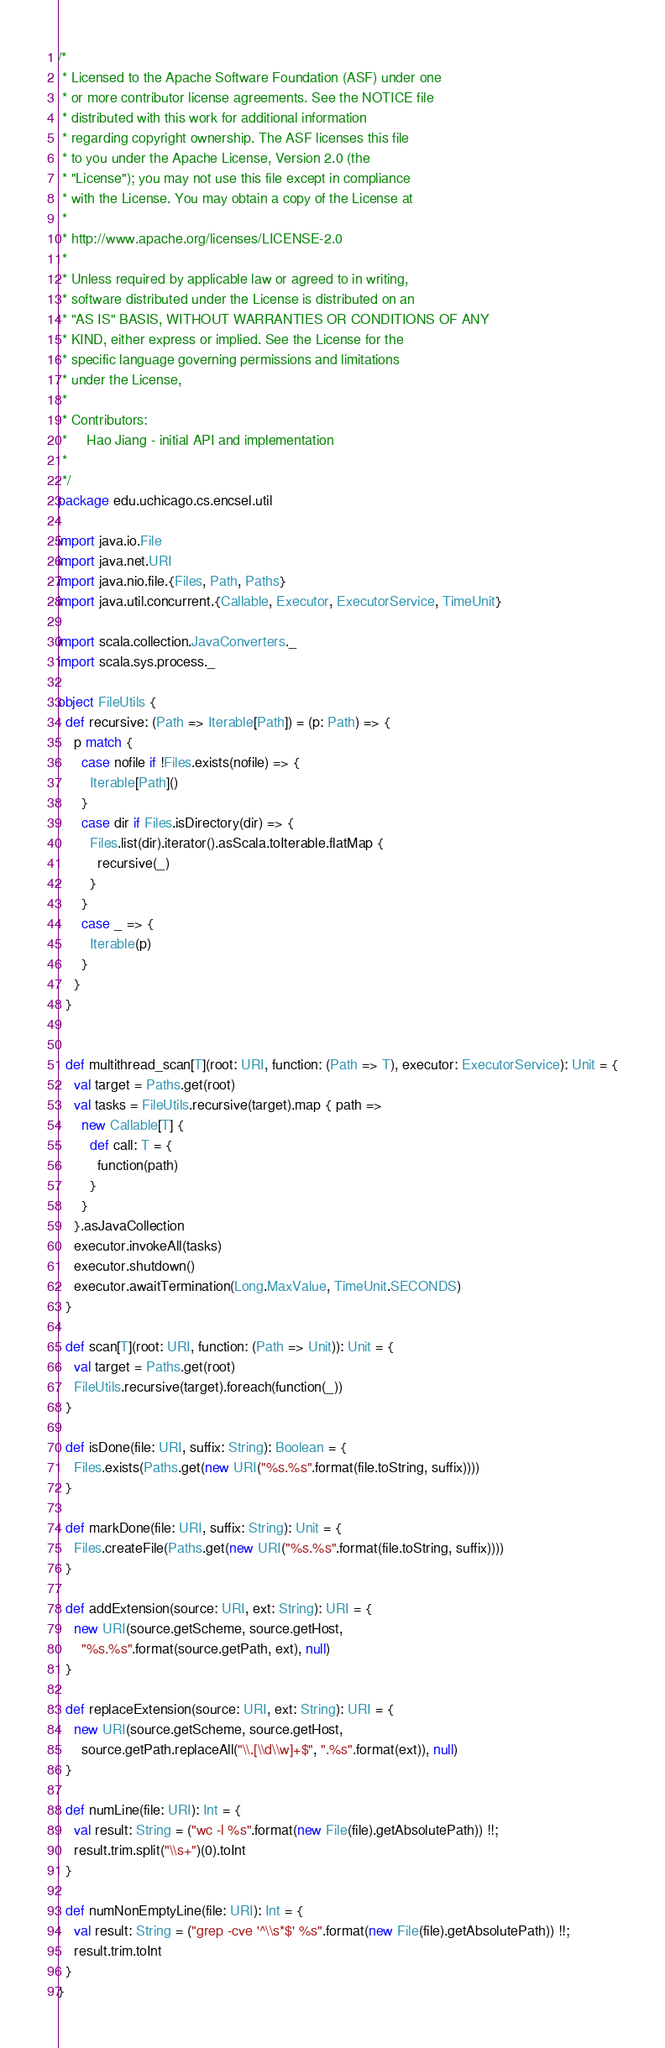Convert code to text. <code><loc_0><loc_0><loc_500><loc_500><_Scala_>/*
 * Licensed to the Apache Software Foundation (ASF) under one
 * or more contributor license agreements. See the NOTICE file
 * distributed with this work for additional information
 * regarding copyright ownership. The ASF licenses this file
 * to you under the Apache License, Version 2.0 (the
 * "License"); you may not use this file except in compliance
 * with the License. You may obtain a copy of the License at
 *
 * http://www.apache.org/licenses/LICENSE-2.0
 *
 * Unless required by applicable law or agreed to in writing,
 * software distributed under the License is distributed on an
 * "AS IS" BASIS, WITHOUT WARRANTIES OR CONDITIONS OF ANY
 * KIND, either express or implied. See the License for the
 * specific language governing permissions and limitations
 * under the License,
 *
 * Contributors:
 *     Hao Jiang - initial API and implementation
 *
 */
package edu.uchicago.cs.encsel.util

import java.io.File
import java.net.URI
import java.nio.file.{Files, Path, Paths}
import java.util.concurrent.{Callable, Executor, ExecutorService, TimeUnit}

import scala.collection.JavaConverters._
import scala.sys.process._

object FileUtils {
  def recursive: (Path => Iterable[Path]) = (p: Path) => {
    p match {
      case nofile if !Files.exists(nofile) => {
        Iterable[Path]()
      }
      case dir if Files.isDirectory(dir) => {
        Files.list(dir).iterator().asScala.toIterable.flatMap {
          recursive(_)
        }
      }
      case _ => {
        Iterable(p)
      }
    }
  }


  def multithread_scan[T](root: URI, function: (Path => T), executor: ExecutorService): Unit = {
    val target = Paths.get(root)
    val tasks = FileUtils.recursive(target).map { path =>
      new Callable[T] {
        def call: T = {
          function(path)
        }
      }
    }.asJavaCollection
    executor.invokeAll(tasks)
    executor.shutdown()
    executor.awaitTermination(Long.MaxValue, TimeUnit.SECONDS)
  }

  def scan[T](root: URI, function: (Path => Unit)): Unit = {
    val target = Paths.get(root)
    FileUtils.recursive(target).foreach(function(_))
  }

  def isDone(file: URI, suffix: String): Boolean = {
    Files.exists(Paths.get(new URI("%s.%s".format(file.toString, suffix))))
  }

  def markDone(file: URI, suffix: String): Unit = {
    Files.createFile(Paths.get(new URI("%s.%s".format(file.toString, suffix))))
  }

  def addExtension(source: URI, ext: String): URI = {
    new URI(source.getScheme, source.getHost,
      "%s.%s".format(source.getPath, ext), null)
  }

  def replaceExtension(source: URI, ext: String): URI = {
    new URI(source.getScheme, source.getHost,
      source.getPath.replaceAll("\\.[\\d\\w]+$", ".%s".format(ext)), null)
  }

  def numLine(file: URI): Int = {
    val result: String = ("wc -l %s".format(new File(file).getAbsolutePath)) !!;
    result.trim.split("\\s+")(0).toInt
  }

  def numNonEmptyLine(file: URI): Int = {
    val result: String = ("grep -cve '^\\s*$' %s".format(new File(file).getAbsolutePath)) !!;
    result.trim.toInt
  }
}</code> 